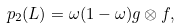Convert formula to latex. <formula><loc_0><loc_0><loc_500><loc_500>p _ { 2 } ( L ) = \omega ( 1 - \omega ) g \otimes f ,</formula> 